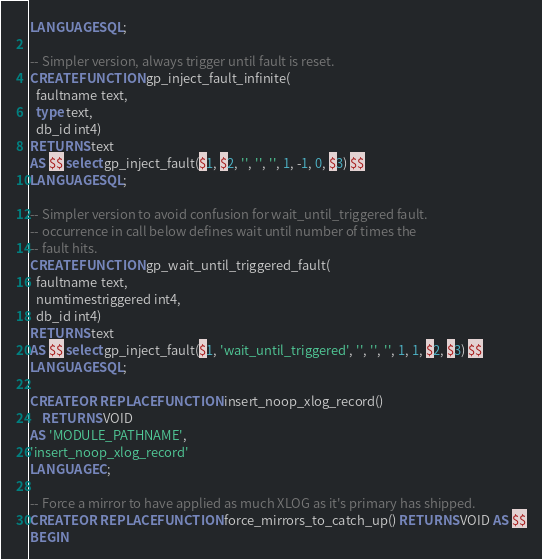<code> <loc_0><loc_0><loc_500><loc_500><_SQL_>LANGUAGE SQL;

-- Simpler version, always trigger until fault is reset.
CREATE FUNCTION gp_inject_fault_infinite(
  faultname text,
  type text,
  db_id int4)
RETURNS text
AS $$ select gp_inject_fault($1, $2, '', '', '', 1, -1, 0, $3) $$
LANGUAGE SQL;

-- Simpler version to avoid confusion for wait_until_triggered fault.
-- occurrence in call below defines wait until number of times the
-- fault hits.
CREATE FUNCTION gp_wait_until_triggered_fault(
  faultname text,
  numtimestriggered int4,
  db_id int4)
RETURNS text
AS $$ select gp_inject_fault($1, 'wait_until_triggered', '', '', '', 1, 1, $2, $3) $$
LANGUAGE SQL;

CREATE OR REPLACE FUNCTION insert_noop_xlog_record()
    RETURNS VOID
AS 'MODULE_PATHNAME',
'insert_noop_xlog_record'
LANGUAGE C;

-- Force a mirror to have applied as much XLOG as it's primary has shipped.
CREATE OR REPLACE FUNCTION force_mirrors_to_catch_up() RETURNS VOID AS $$
BEGIN</code> 